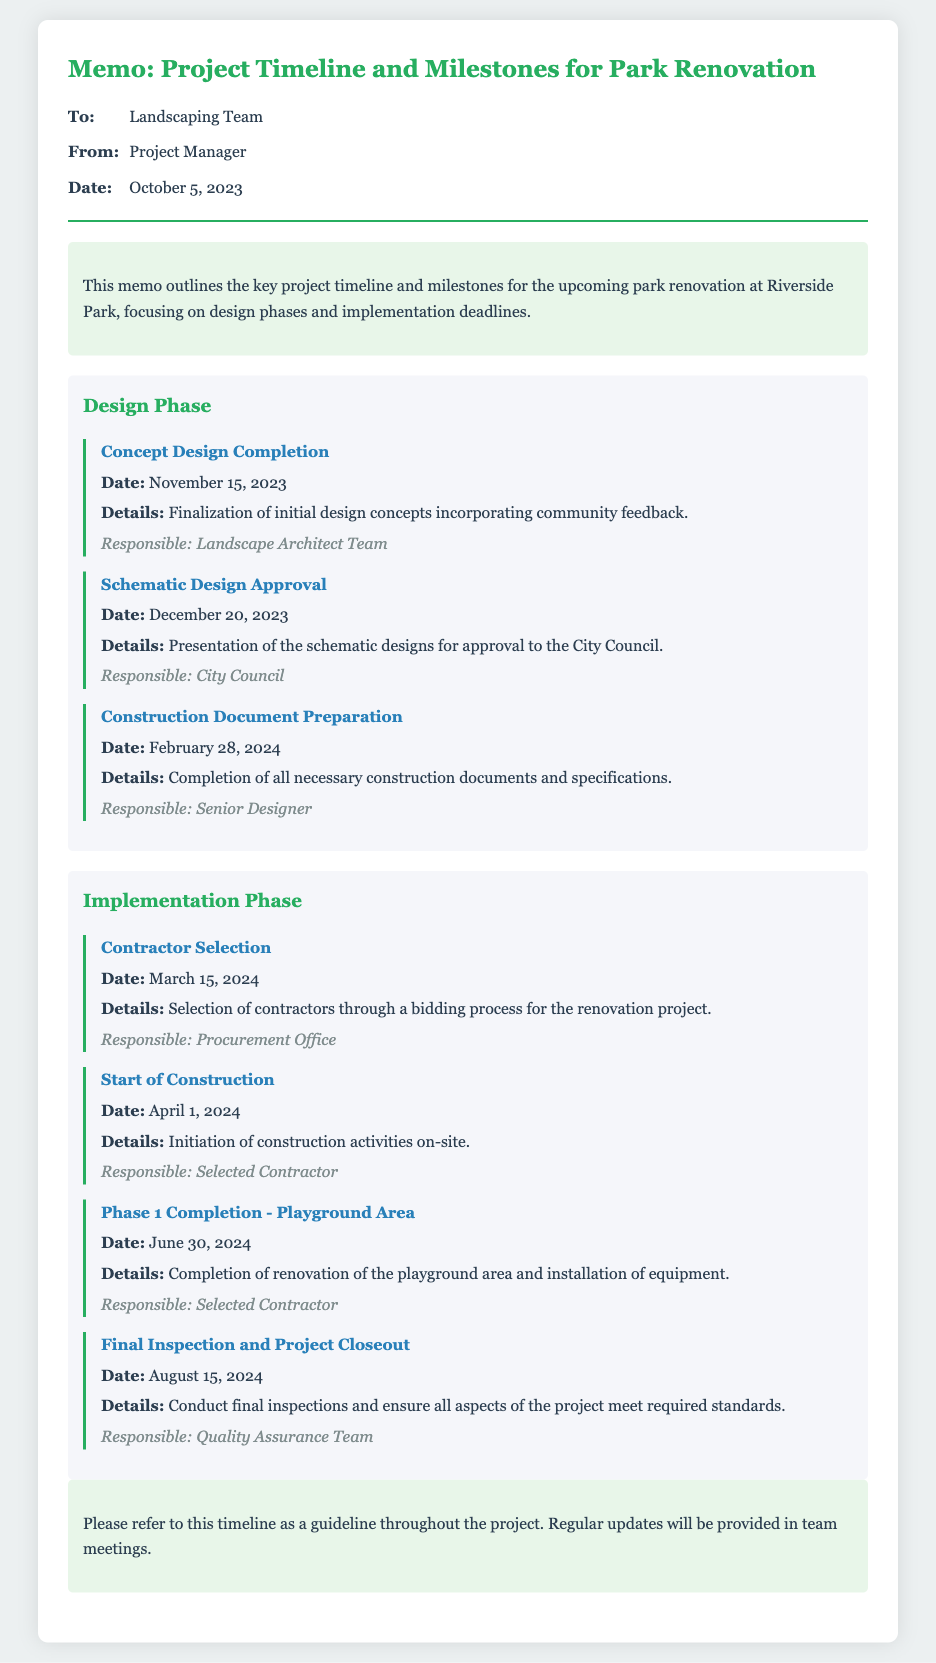what is the date for the Concept Design Completion? The date for the Concept Design Completion milestone is specified in the document.
Answer: November 15, 2023 who is responsible for the Schematic Design Approval? The document mentions the responsible party for the Schematic Design Approval milestone.
Answer: City Council what is the completion date for the playground area renovation? The renovation completion date for the playground area is found in the Implementation Phase of the document.
Answer: June 30, 2024 what milestone follows the Contractor Selection? The document outlines the sequence of milestones in the Implementation Phase.
Answer: Start of Construction who is responsible for the final inspection and project closeout? The document specifies the responsible party for the final inspection and project closeout task.
Answer: Quality Assurance Team how many design phase milestones are listed in the document? The document provides details about the number of milestones under the Design Phase.
Answer: Three when is the completion date for the Construction Document Preparation? The date for the completion of Construction Document Preparation is detailed in the Design Phase.
Answer: February 28, 2024 what is the title of this document? The document's title is clearly stated at the beginning.
Answer: Memo: Project Timeline and Milestones for Park Renovation 